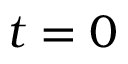<formula> <loc_0><loc_0><loc_500><loc_500>t = 0</formula> 